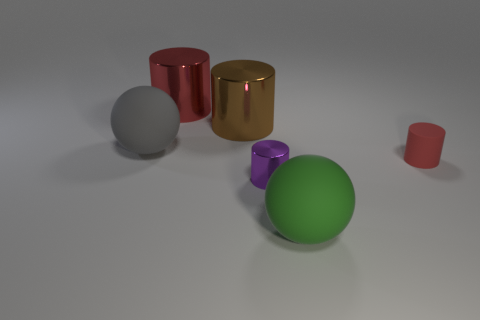What number of other objects are the same size as the brown cylinder?
Offer a terse response. 3. There is a small red thing; does it have the same shape as the shiny object in front of the big gray rubber object?
Provide a short and direct response. Yes. What number of shiny objects are tiny brown cubes or green objects?
Offer a very short reply. 0. Is there a object of the same color as the rubber cylinder?
Offer a very short reply. Yes. Are there any large yellow metal things?
Ensure brevity in your answer.  No. Is the gray rubber object the same shape as the large green matte thing?
Give a very brief answer. Yes. What number of large objects are purple cylinders or red metal cylinders?
Your answer should be compact. 1. What color is the tiny matte object?
Your answer should be very brief. Red. The small object left of the red thing on the right side of the large red cylinder is what shape?
Make the answer very short. Cylinder. Is there a purple ball that has the same material as the tiny purple cylinder?
Give a very brief answer. No. 